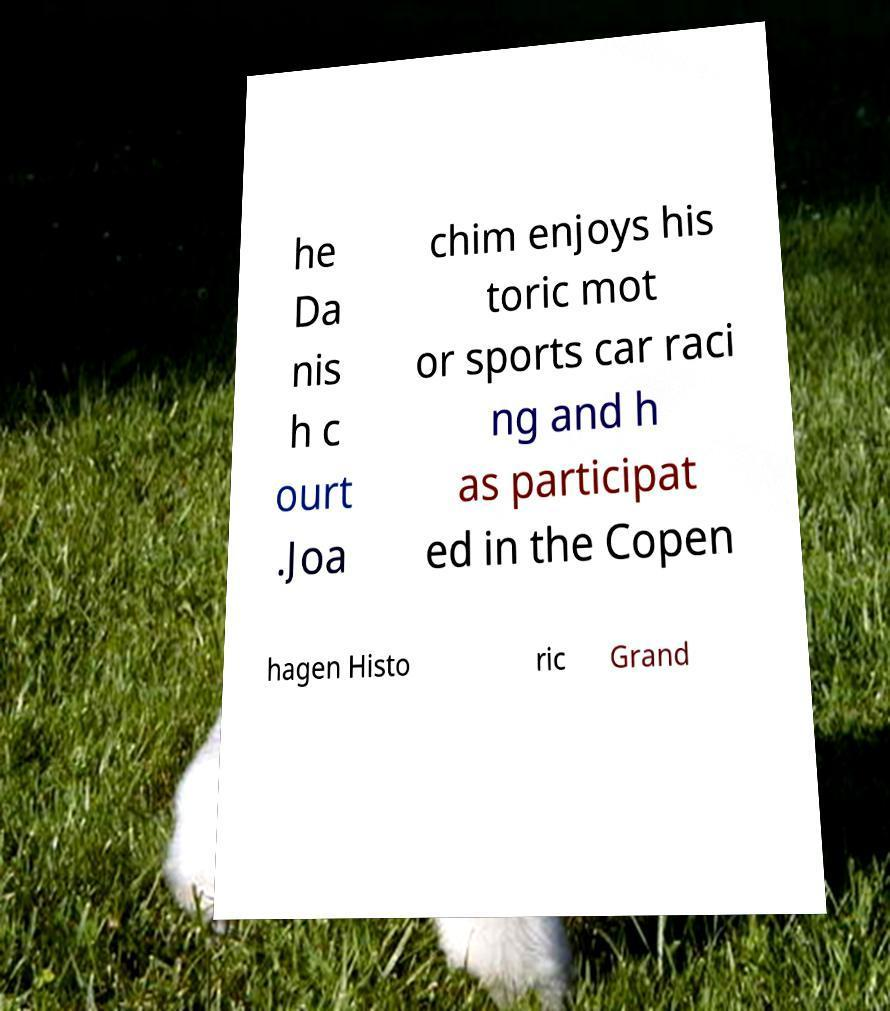For documentation purposes, I need the text within this image transcribed. Could you provide that? he Da nis h c ourt .Joa chim enjoys his toric mot or sports car raci ng and h as participat ed in the Copen hagen Histo ric Grand 